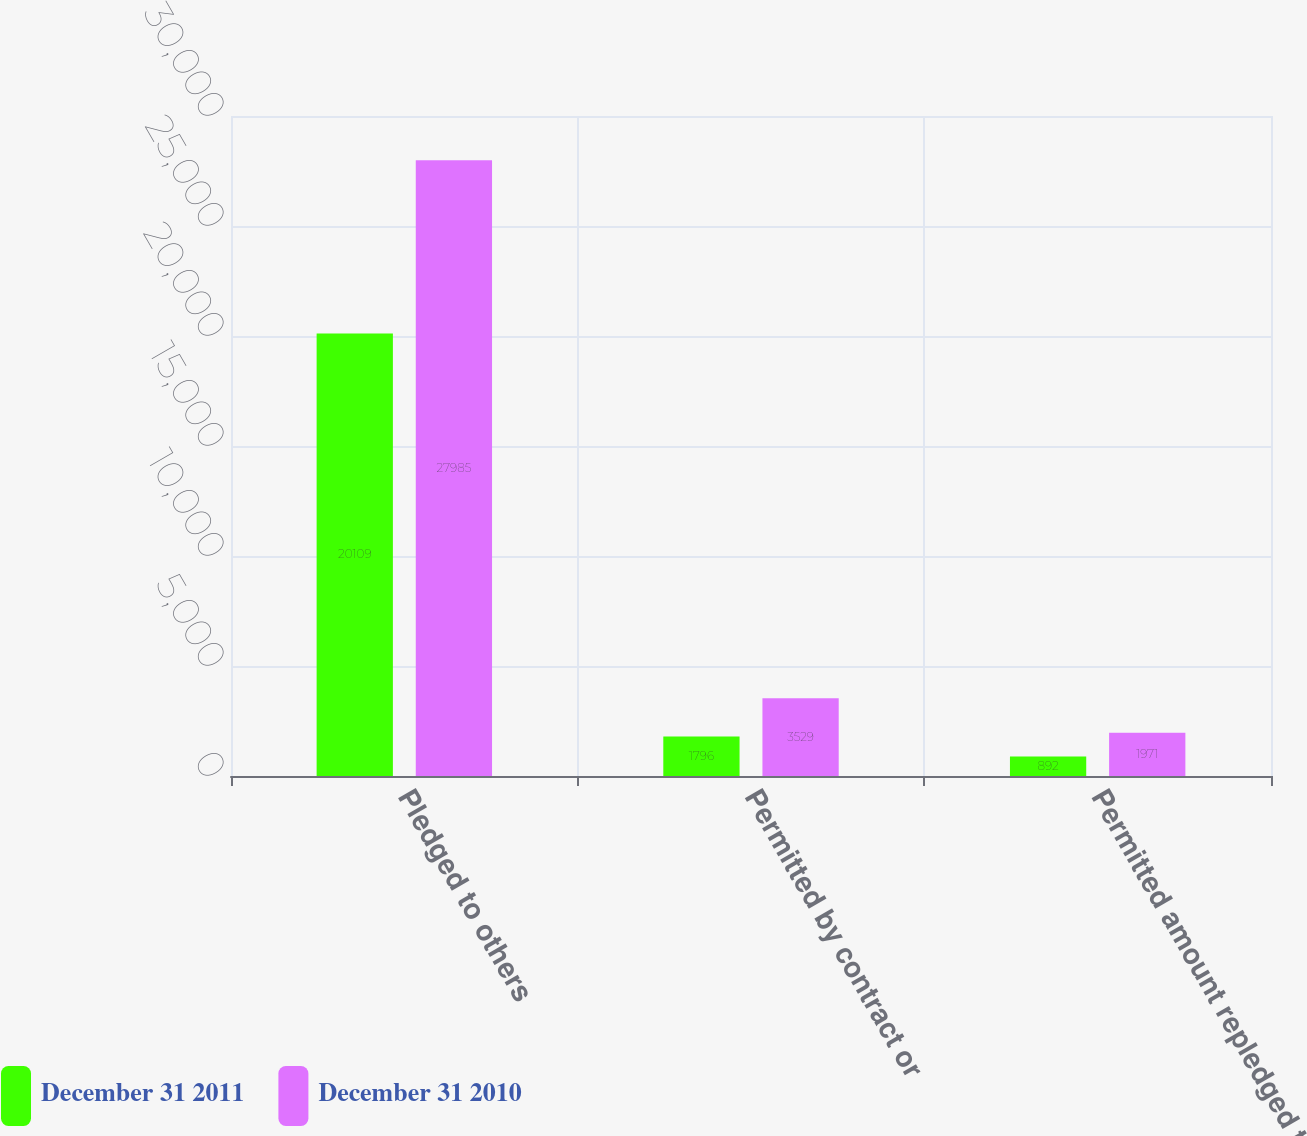<chart> <loc_0><loc_0><loc_500><loc_500><stacked_bar_chart><ecel><fcel>Pledged to others<fcel>Permitted by contract or<fcel>Permitted amount repledged to<nl><fcel>December 31 2011<fcel>20109<fcel>1796<fcel>892<nl><fcel>December 31 2010<fcel>27985<fcel>3529<fcel>1971<nl></chart> 